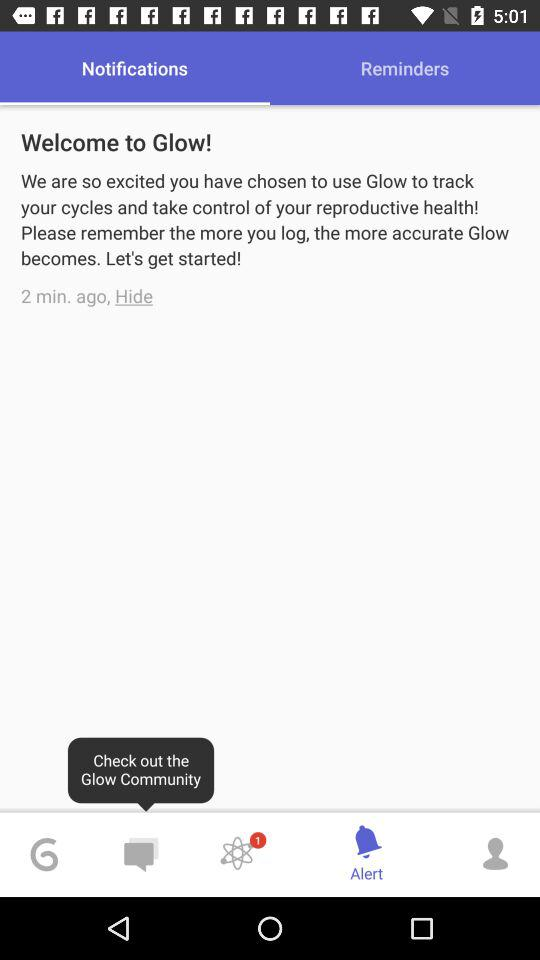When was the notification "Welcome to Glow!" received? The notification was received 2 minutes ago. 